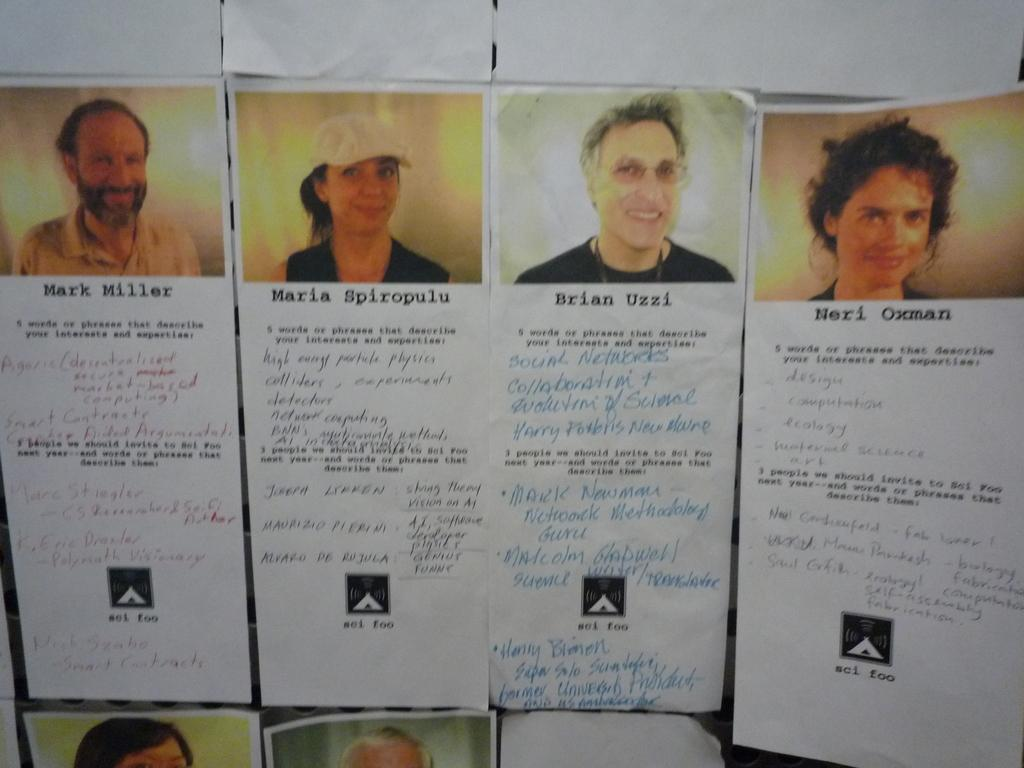How many people are in the image? There are six persons in the image. What is a common feature among all the people in the image? There is text written on each person. What type of base can be seen supporting the basketball court in the image? There is no basketball court or base present in the image. How many cattle are visible in the image? There are no cattle present in the image. 